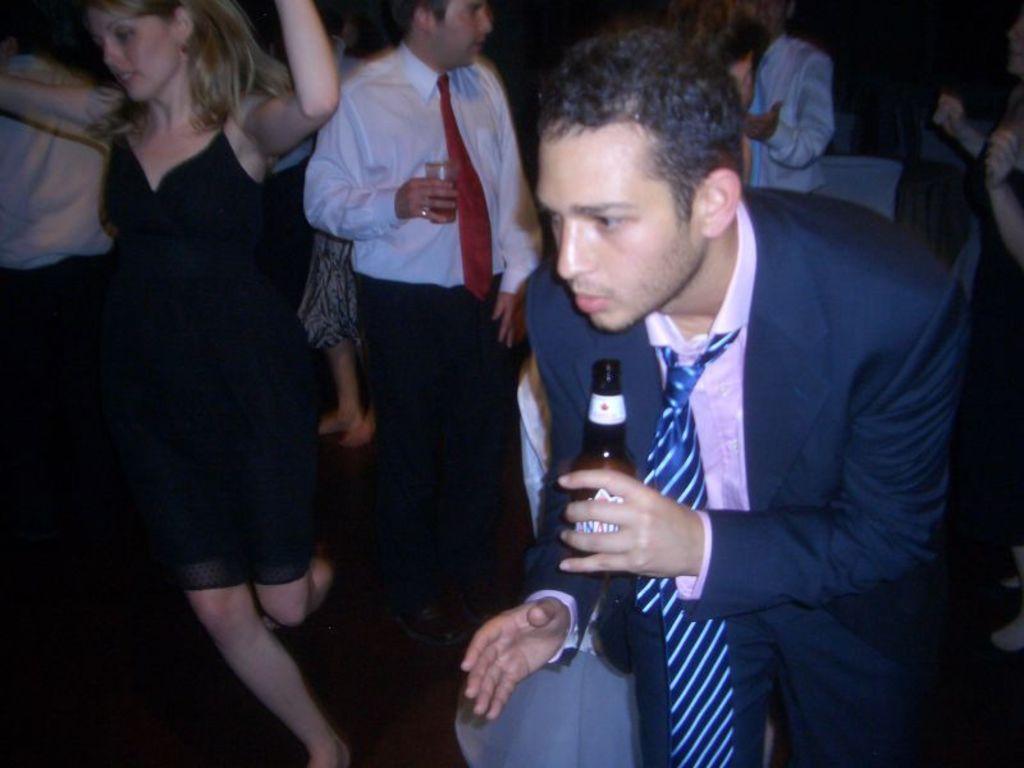Could you give a brief overview of what you see in this image? In this image we can see a man on the right side and he is holding a beer bottle in his left hand. He is wearing a suit and a tie. Here we can see a woman dancing on the floor and she is on the left side. In the background, we can see a few persons. Here we can see another man wearing a white color shirt and he is holding a glass in his right hand. 